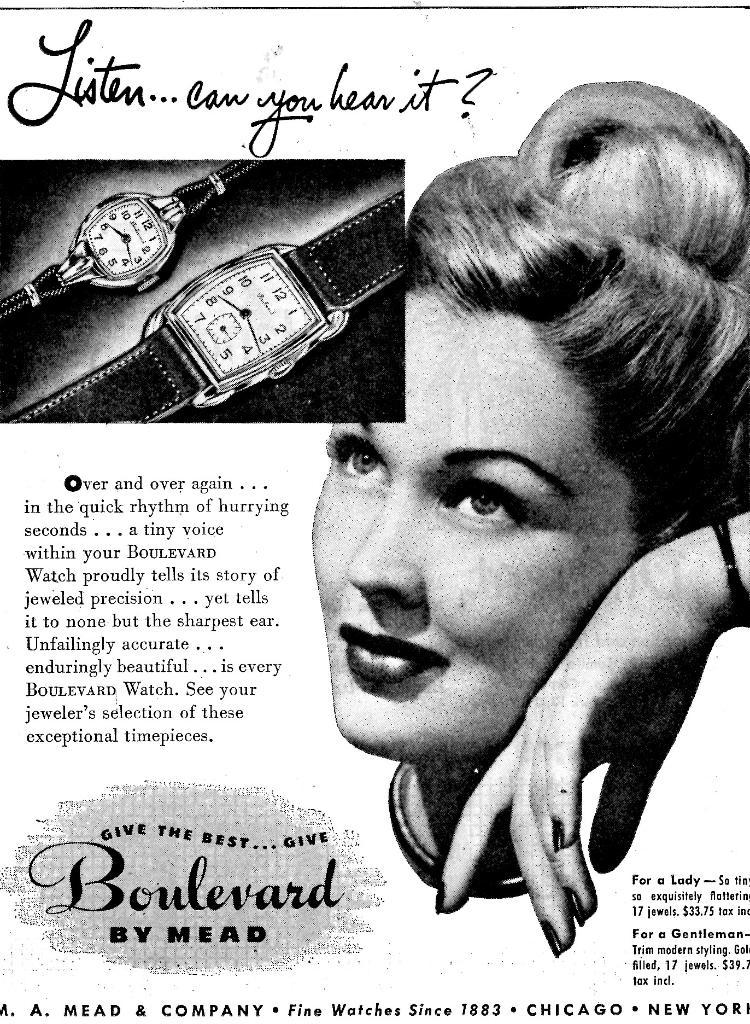Provide a one-sentence caption for the provided image. A poster advertisement in black and white with a woman featured leaning on her hand and the phrase "Listen, can you hear it?" above a picture of two watches. 